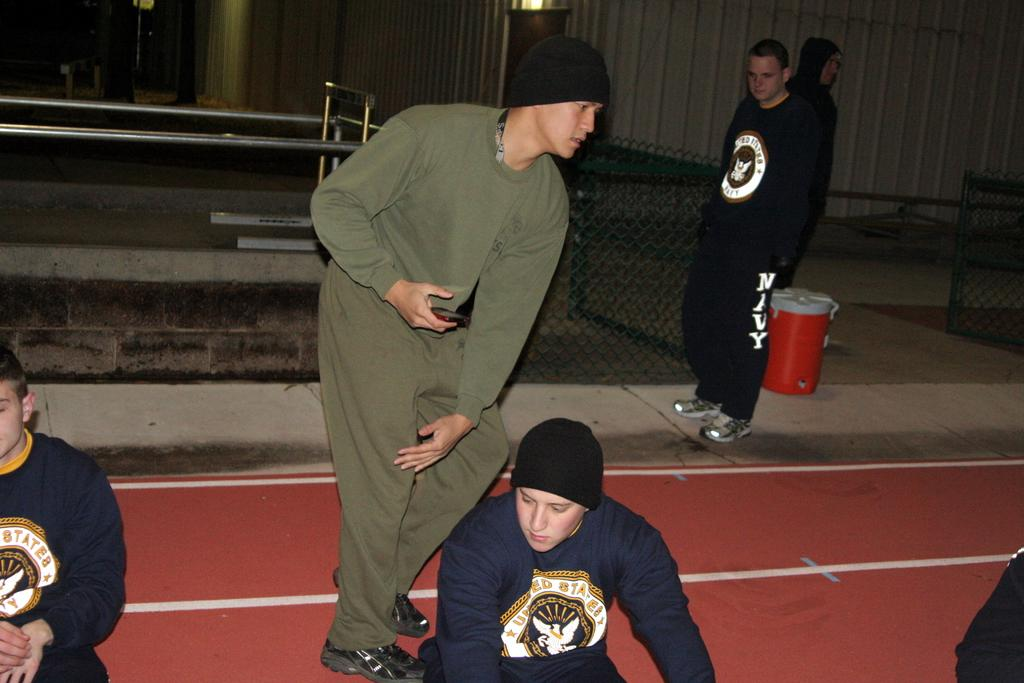<image>
Relay a brief, clear account of the picture shown. Man wearing a sweater and pants which say NAVY watching other men. 